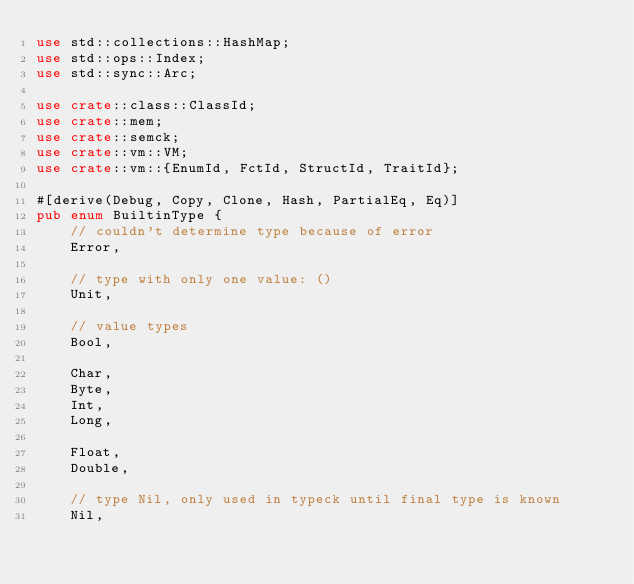Convert code to text. <code><loc_0><loc_0><loc_500><loc_500><_Rust_>use std::collections::HashMap;
use std::ops::Index;
use std::sync::Arc;

use crate::class::ClassId;
use crate::mem;
use crate::semck;
use crate::vm::VM;
use crate::vm::{EnumId, FctId, StructId, TraitId};

#[derive(Debug, Copy, Clone, Hash, PartialEq, Eq)]
pub enum BuiltinType {
    // couldn't determine type because of error
    Error,

    // type with only one value: ()
    Unit,

    // value types
    Bool,

    Char,
    Byte,
    Int,
    Long,

    Float,
    Double,

    // type Nil, only used in typeck until final type is known
    Nil,
</code> 